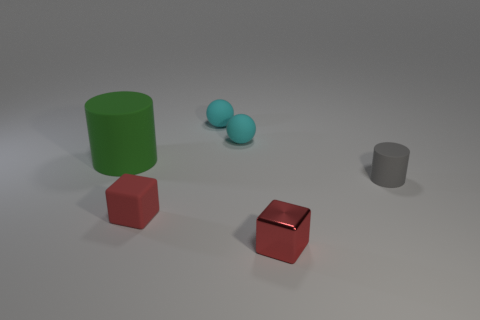Add 4 big purple metallic spheres. How many objects exist? 10 Subtract all blocks. How many objects are left? 4 Add 2 red matte things. How many red matte things are left? 3 Add 3 big purple things. How many big purple things exist? 3 Subtract 0 purple blocks. How many objects are left? 6 Subtract all blue objects. Subtract all cylinders. How many objects are left? 4 